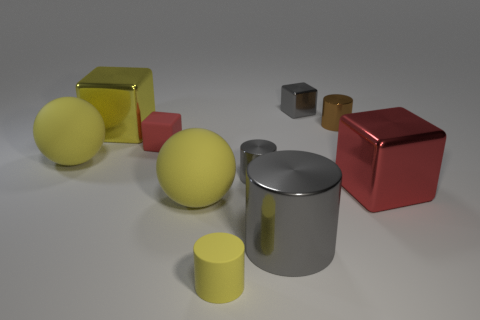Subtract all tiny red matte blocks. How many blocks are left? 3 Subtract all yellow balls. How many gray cylinders are left? 2 Subtract all yellow cylinders. How many cylinders are left? 3 Subtract all blocks. How many objects are left? 6 Subtract all green cylinders. Subtract all purple balls. How many cylinders are left? 4 Subtract all small gray cylinders. Subtract all tiny red objects. How many objects are left? 8 Add 8 yellow balls. How many yellow balls are left? 10 Add 7 big gray objects. How many big gray objects exist? 8 Subtract 1 red cubes. How many objects are left? 9 